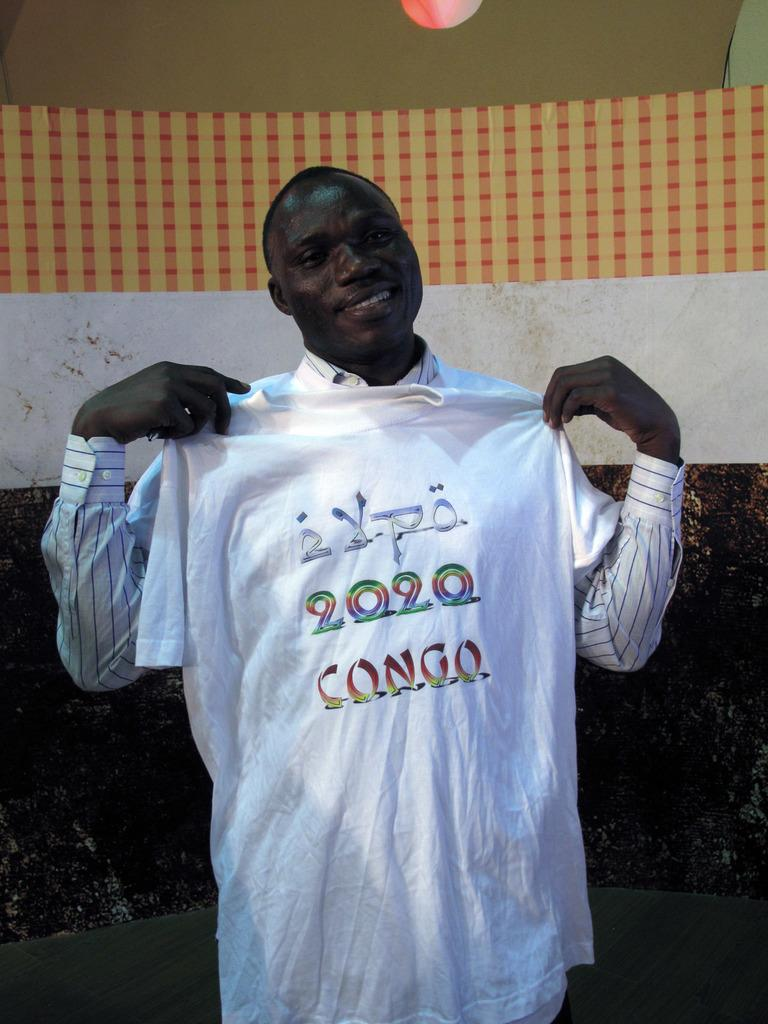Provide a one-sentence caption for the provided image. a man holding a 2020 shirt in his arms. 